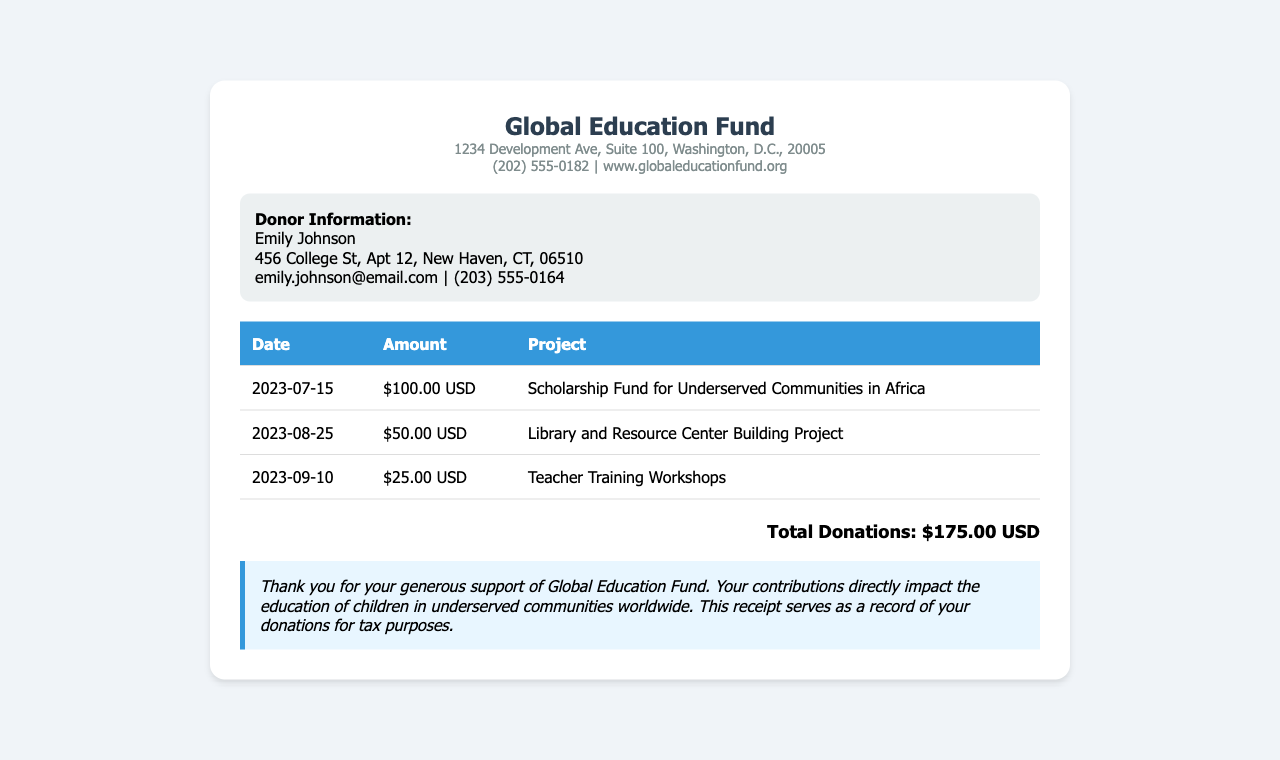What is the name of the NGO? The NGO is referred to as the Global Education Fund in the document.
Answer: Global Education Fund Who is the donor? The document lists the donor's name as Emily Johnson.
Answer: Emily Johnson What is the total donation amount? The total donation amount is calculated from all individual donations listed in the document, which adds up to $175.00 USD.
Answer: $175.00 USD How much was donated on July 15, 2023? The amount donated on that date is found in the first row of the donation table.
Answer: $100.00 USD What project received the $50 donation? The document specifies the project associated with the $50 donation in the second row of the table.
Answer: Library and Resource Center Building Project What is the purpose of this receipt? The purpose is detailed in the acknowledgment section of the document, which serves as a record for tax purposes.
Answer: Tax purposes How many donations are listed in the table? By counting the number of rows in the donation table, including the headers, we find there are three listed donations.
Answer: 3 What date was the last donation made? The date of the last donation is provided in the last row of the table.
Answer: 2023-09-10 